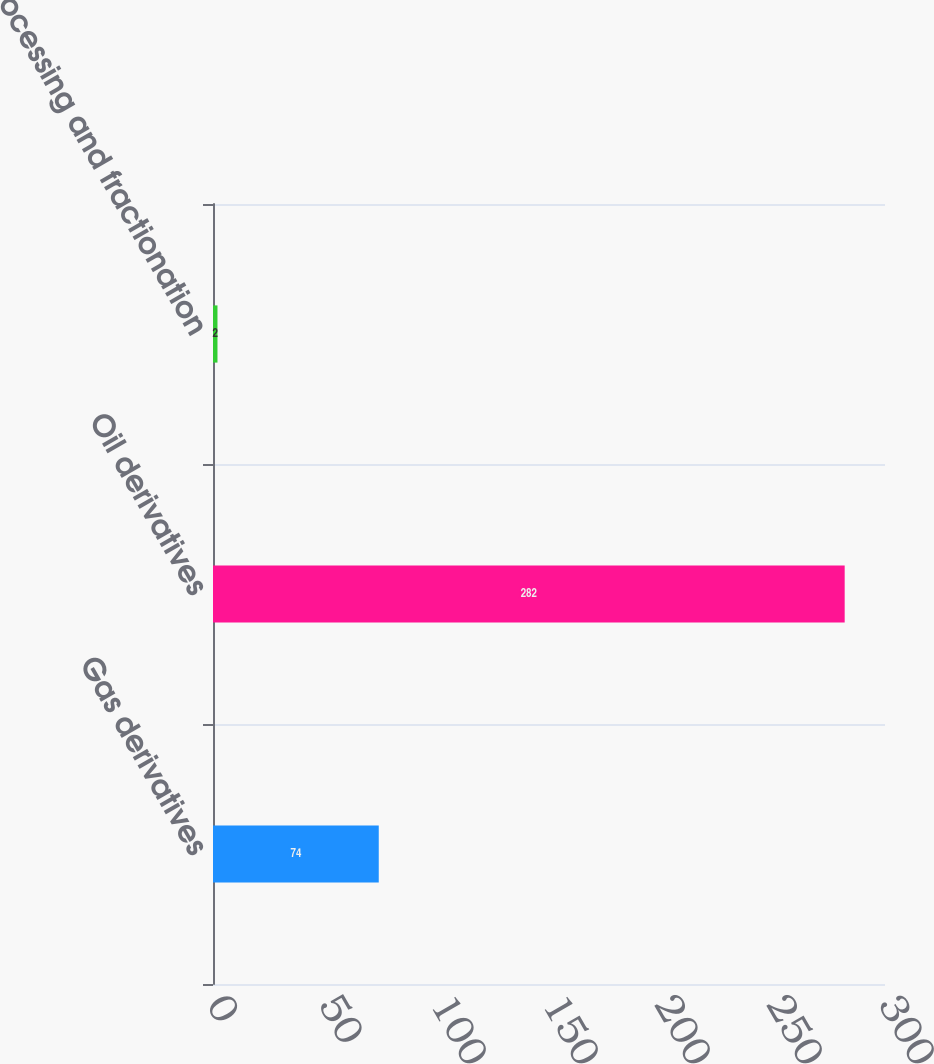Convert chart to OTSL. <chart><loc_0><loc_0><loc_500><loc_500><bar_chart><fcel>Gas derivatives<fcel>Oil derivatives<fcel>Processing and fractionation<nl><fcel>74<fcel>282<fcel>2<nl></chart> 